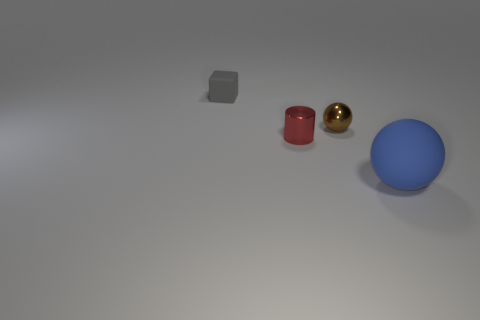Can you tell me the colors of the objects from left to right? The objects display the following colors from left to right: gray, brown, gold, and blue. 